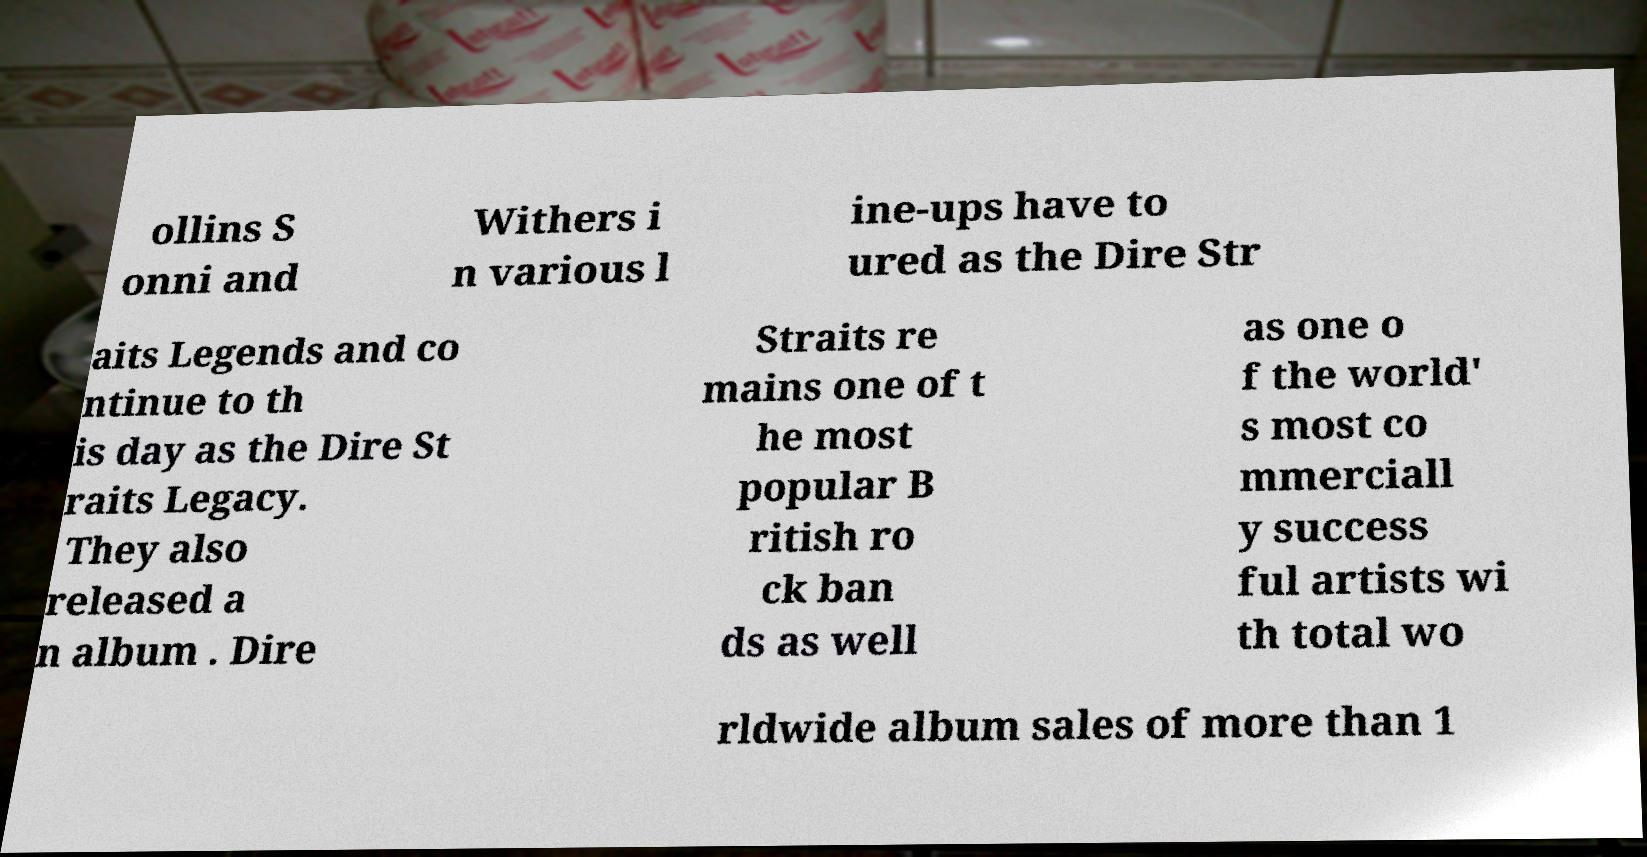Could you extract and type out the text from this image? ollins S onni and Withers i n various l ine-ups have to ured as the Dire Str aits Legends and co ntinue to th is day as the Dire St raits Legacy. They also released a n album . Dire Straits re mains one of t he most popular B ritish ro ck ban ds as well as one o f the world' s most co mmerciall y success ful artists wi th total wo rldwide album sales of more than 1 